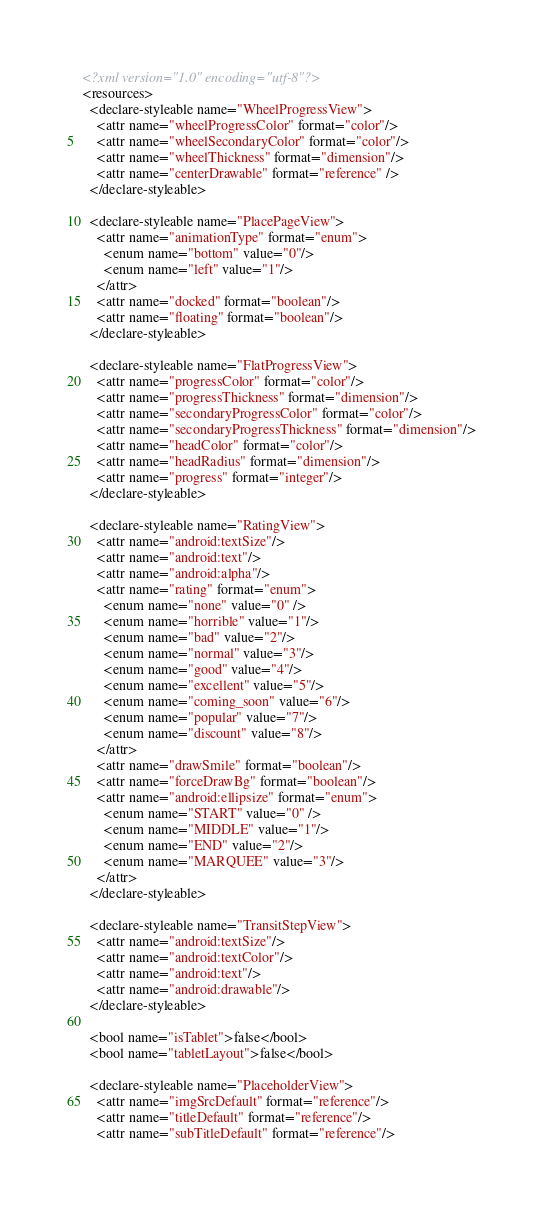Convert code to text. <code><loc_0><loc_0><loc_500><loc_500><_XML_><?xml version="1.0" encoding="utf-8"?>
<resources>
  <declare-styleable name="WheelProgressView">
    <attr name="wheelProgressColor" format="color"/>
    <attr name="wheelSecondaryColor" format="color"/>
    <attr name="wheelThickness" format="dimension"/>
    <attr name="centerDrawable" format="reference" />
  </declare-styleable>

  <declare-styleable name="PlacePageView">
    <attr name="animationType" format="enum">
      <enum name="bottom" value="0"/>
      <enum name="left" value="1"/>
    </attr>
    <attr name="docked" format="boolean"/>
    <attr name="floating" format="boolean"/>
  </declare-styleable>

  <declare-styleable name="FlatProgressView">
    <attr name="progressColor" format="color"/>
    <attr name="progressThickness" format="dimension"/>
    <attr name="secondaryProgressColor" format="color"/>
    <attr name="secondaryProgressThickness" format="dimension"/>
    <attr name="headColor" format="color"/>
    <attr name="headRadius" format="dimension"/>
    <attr name="progress" format="integer"/>
  </declare-styleable>

  <declare-styleable name="RatingView">
    <attr name="android:textSize"/>
    <attr name="android:text"/>
    <attr name="android:alpha"/>
    <attr name="rating" format="enum">
      <enum name="none" value="0" />
      <enum name="horrible" value="1"/>
      <enum name="bad" value="2"/>
      <enum name="normal" value="3"/>
      <enum name="good" value="4"/>
      <enum name="excellent" value="5"/>
      <enum name="coming_soon" value="6"/>
      <enum name="popular" value="7"/>
      <enum name="discount" value="8"/>
    </attr>
    <attr name="drawSmile" format="boolean"/>
    <attr name="forceDrawBg" format="boolean"/>
    <attr name="android:ellipsize" format="enum">
      <enum name="START" value="0" />
      <enum name="MIDDLE" value="1"/>
      <enum name="END" value="2"/>
      <enum name="MARQUEE" value="3"/>
    </attr>
  </declare-styleable>

  <declare-styleable name="TransitStepView">
    <attr name="android:textSize"/>
    <attr name="android:textColor"/>
    <attr name="android:text"/>
    <attr name="android:drawable"/>
  </declare-styleable>

  <bool name="isTablet">false</bool>
  <bool name="tabletLayout">false</bool>

  <declare-styleable name="PlaceholderView">
    <attr name="imgSrcDefault" format="reference"/>
    <attr name="titleDefault" format="reference"/>
    <attr name="subTitleDefault" format="reference"/></code> 